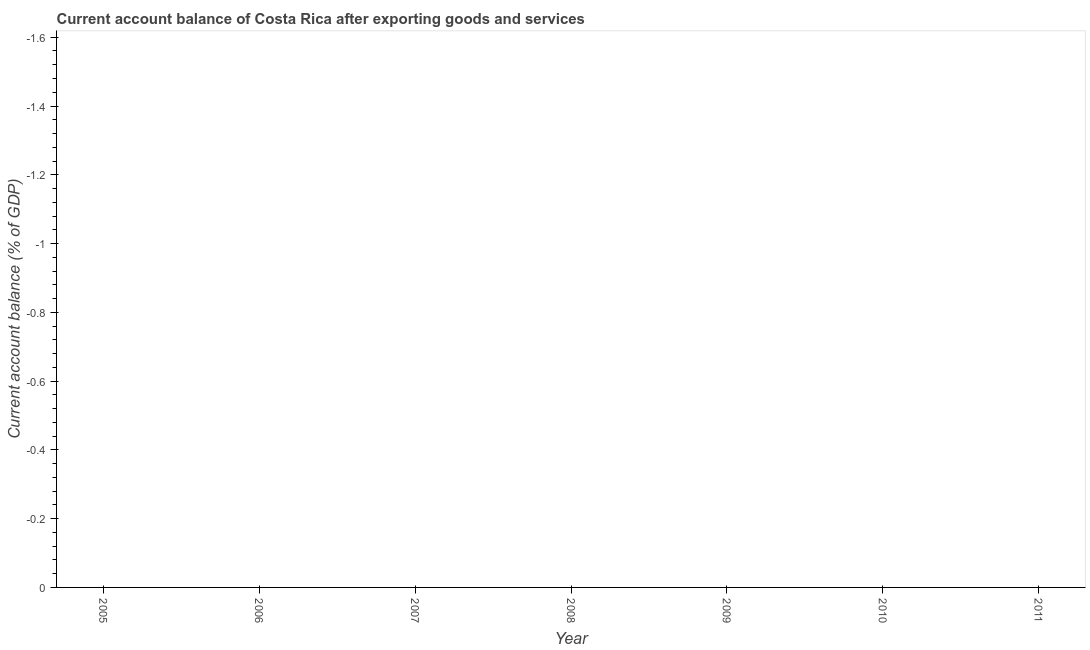What is the median current account balance?
Make the answer very short. 0. In how many years, is the current account balance greater than -1.52 %?
Your answer should be compact. 0. How many lines are there?
Keep it short and to the point. 0. How many years are there in the graph?
Ensure brevity in your answer.  7. What is the difference between two consecutive major ticks on the Y-axis?
Provide a short and direct response. 0.2. Does the graph contain grids?
Offer a terse response. No. What is the title of the graph?
Give a very brief answer. Current account balance of Costa Rica after exporting goods and services. What is the label or title of the X-axis?
Your answer should be compact. Year. What is the label or title of the Y-axis?
Give a very brief answer. Current account balance (% of GDP). What is the Current account balance (% of GDP) in 2006?
Make the answer very short. 0. What is the Current account balance (% of GDP) of 2008?
Make the answer very short. 0. What is the Current account balance (% of GDP) of 2009?
Your answer should be compact. 0. What is the Current account balance (% of GDP) of 2010?
Give a very brief answer. 0. What is the Current account balance (% of GDP) in 2011?
Your answer should be compact. 0. 